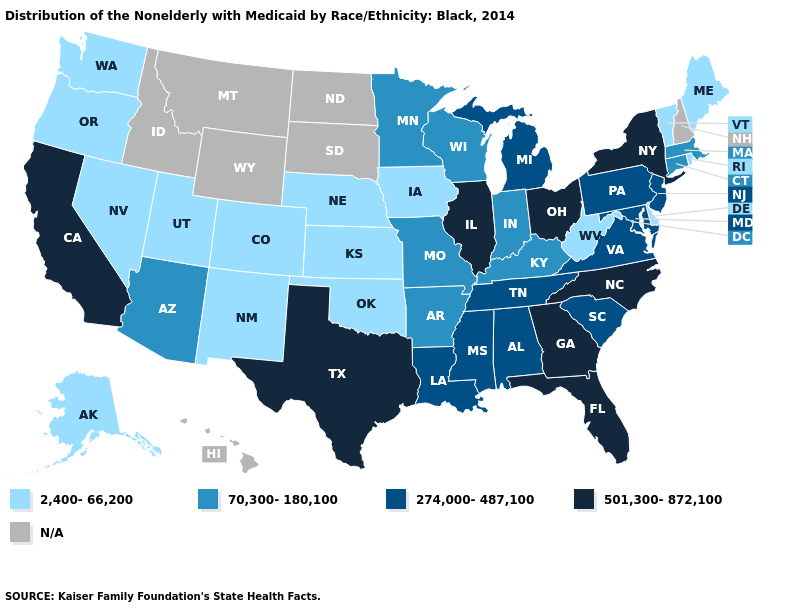What is the value of Louisiana?
Write a very short answer. 274,000-487,100. What is the highest value in the USA?
Keep it brief. 501,300-872,100. What is the lowest value in the West?
Write a very short answer. 2,400-66,200. What is the lowest value in the MidWest?
Short answer required. 2,400-66,200. How many symbols are there in the legend?
Concise answer only. 5. How many symbols are there in the legend?
Keep it brief. 5. Name the states that have a value in the range 274,000-487,100?
Keep it brief. Alabama, Louisiana, Maryland, Michigan, Mississippi, New Jersey, Pennsylvania, South Carolina, Tennessee, Virginia. Name the states that have a value in the range 274,000-487,100?
Concise answer only. Alabama, Louisiana, Maryland, Michigan, Mississippi, New Jersey, Pennsylvania, South Carolina, Tennessee, Virginia. Does the map have missing data?
Be succinct. Yes. What is the highest value in the USA?
Quick response, please. 501,300-872,100. What is the highest value in the USA?
Short answer required. 501,300-872,100. What is the highest value in the USA?
Give a very brief answer. 501,300-872,100. What is the value of New York?
Short answer required. 501,300-872,100. Name the states that have a value in the range 274,000-487,100?
Short answer required. Alabama, Louisiana, Maryland, Michigan, Mississippi, New Jersey, Pennsylvania, South Carolina, Tennessee, Virginia. 